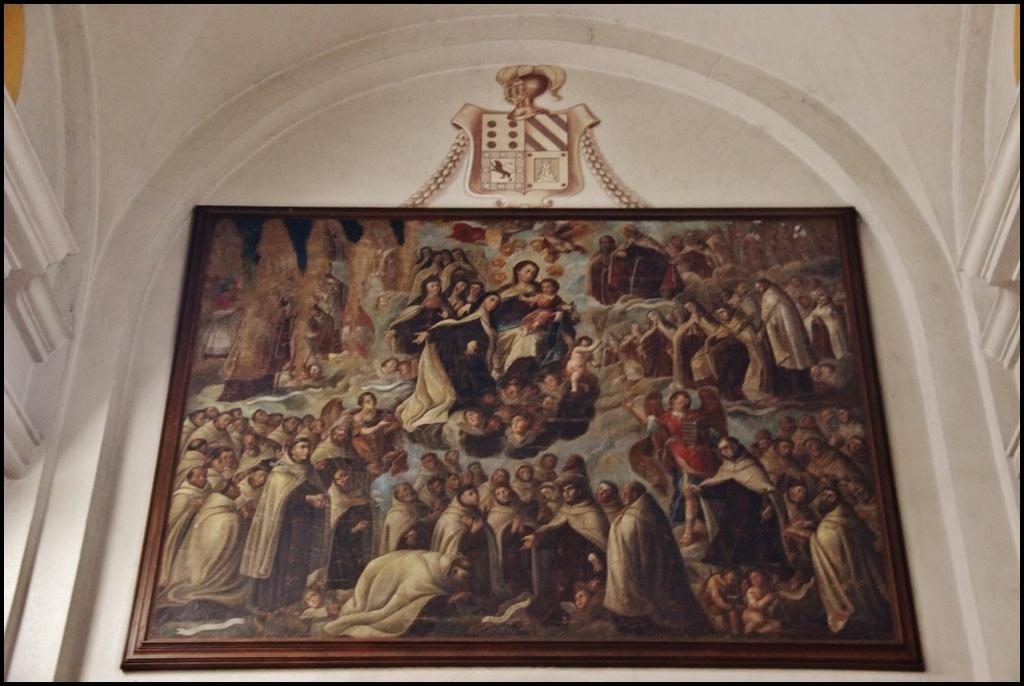What is depicted within the frame in the image? There is a painting in the frame in the image. Where is the frame located in the image? The frame is on the wall in the image. What type of behavior can be observed in the painting within the frame? There is no behavior to observe in the painting within the frame, as it is a still image. What type of powder is used to create the painting within the frame? There is no information about the materials used to create the painting within the frame. 